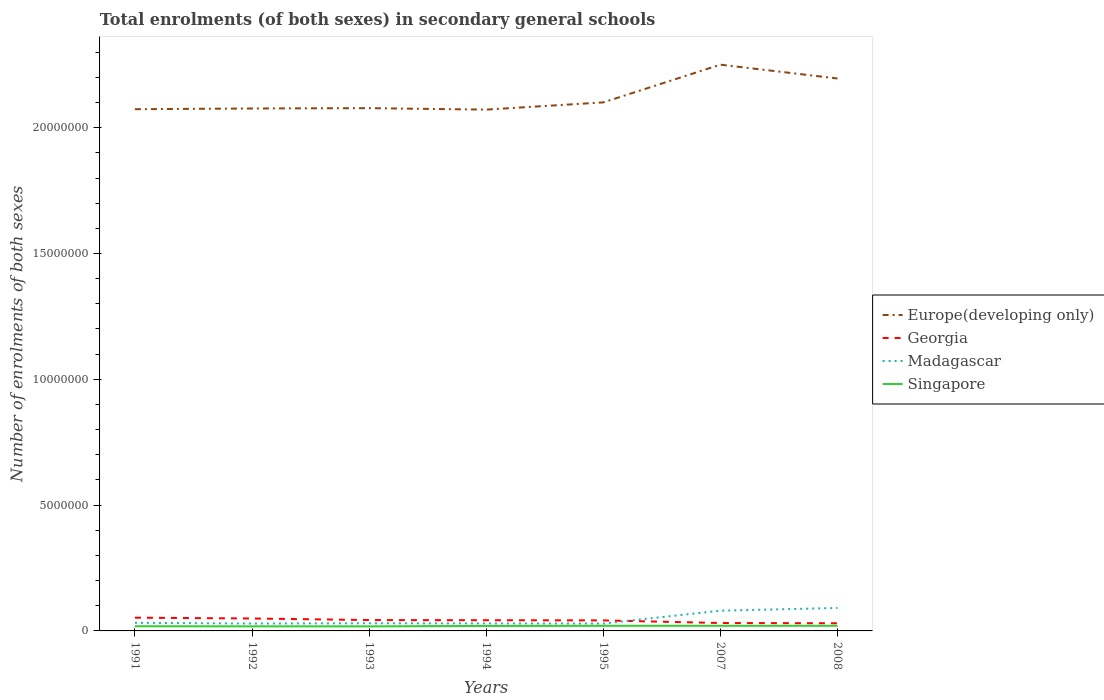Does the line corresponding to Madagascar intersect with the line corresponding to Europe(developing only)?
Provide a succinct answer. No. Across all years, what is the maximum number of enrolments in secondary schools in Europe(developing only)?
Ensure brevity in your answer.  2.07e+07. What is the total number of enrolments in secondary schools in Georgia in the graph?
Offer a very short reply. 1.91e+05. What is the difference between the highest and the second highest number of enrolments in secondary schools in Madagascar?
Offer a terse response. 6.19e+05. What is the difference between the highest and the lowest number of enrolments in secondary schools in Singapore?
Your answer should be very brief. 4. Are the values on the major ticks of Y-axis written in scientific E-notation?
Provide a succinct answer. No. Does the graph contain any zero values?
Offer a terse response. No. What is the title of the graph?
Your answer should be compact. Total enrolments (of both sexes) in secondary general schools. What is the label or title of the X-axis?
Ensure brevity in your answer.  Years. What is the label or title of the Y-axis?
Offer a very short reply. Number of enrolments of both sexes. What is the Number of enrolments of both sexes in Europe(developing only) in 1991?
Offer a terse response. 2.07e+07. What is the Number of enrolments of both sexes in Georgia in 1991?
Ensure brevity in your answer.  5.26e+05. What is the Number of enrolments of both sexes in Madagascar in 1991?
Give a very brief answer. 3.23e+05. What is the Number of enrolments of both sexes in Singapore in 1991?
Keep it short and to the point. 1.86e+05. What is the Number of enrolments of both sexes of Europe(developing only) in 1992?
Provide a succinct answer. 2.08e+07. What is the Number of enrolments of both sexes of Georgia in 1992?
Provide a short and direct response. 4.94e+05. What is the Number of enrolments of both sexes of Madagascar in 1992?
Your answer should be compact. 2.94e+05. What is the Number of enrolments of both sexes of Singapore in 1992?
Your answer should be very brief. 1.82e+05. What is the Number of enrolments of both sexes of Europe(developing only) in 1993?
Give a very brief answer. 2.08e+07. What is the Number of enrolments of both sexes in Georgia in 1993?
Give a very brief answer. 4.32e+05. What is the Number of enrolments of both sexes of Madagascar in 1993?
Keep it short and to the point. 3.05e+05. What is the Number of enrolments of both sexes in Singapore in 1993?
Offer a very short reply. 1.81e+05. What is the Number of enrolments of both sexes in Europe(developing only) in 1994?
Keep it short and to the point. 2.07e+07. What is the Number of enrolments of both sexes of Georgia in 1994?
Offer a terse response. 4.25e+05. What is the Number of enrolments of both sexes in Madagascar in 1994?
Your answer should be compact. 2.98e+05. What is the Number of enrolments of both sexes in Singapore in 1994?
Give a very brief answer. 1.98e+05. What is the Number of enrolments of both sexes of Europe(developing only) in 1995?
Give a very brief answer. 2.10e+07. What is the Number of enrolments of both sexes of Georgia in 1995?
Provide a short and direct response. 4.18e+05. What is the Number of enrolments of both sexes of Madagascar in 1995?
Provide a succinct answer. 2.94e+05. What is the Number of enrolments of both sexes in Singapore in 1995?
Your response must be concise. 2.04e+05. What is the Number of enrolments of both sexes of Europe(developing only) in 2007?
Keep it short and to the point. 2.25e+07. What is the Number of enrolments of both sexes in Georgia in 2007?
Your answer should be very brief. 3.14e+05. What is the Number of enrolments of both sexes in Madagascar in 2007?
Your response must be concise. 8.05e+05. What is the Number of enrolments of both sexes of Singapore in 2007?
Your answer should be very brief. 2.04e+05. What is the Number of enrolments of both sexes in Europe(developing only) in 2008?
Your response must be concise. 2.20e+07. What is the Number of enrolments of both sexes of Georgia in 2008?
Keep it short and to the point. 3.04e+05. What is the Number of enrolments of both sexes of Madagascar in 2008?
Your answer should be compact. 9.12e+05. What is the Number of enrolments of both sexes of Singapore in 2008?
Your answer should be compact. 2.04e+05. Across all years, what is the maximum Number of enrolments of both sexes of Europe(developing only)?
Your response must be concise. 2.25e+07. Across all years, what is the maximum Number of enrolments of both sexes of Georgia?
Give a very brief answer. 5.26e+05. Across all years, what is the maximum Number of enrolments of both sexes in Madagascar?
Keep it short and to the point. 9.12e+05. Across all years, what is the maximum Number of enrolments of both sexes in Singapore?
Keep it short and to the point. 2.04e+05. Across all years, what is the minimum Number of enrolments of both sexes of Europe(developing only)?
Keep it short and to the point. 2.07e+07. Across all years, what is the minimum Number of enrolments of both sexes in Georgia?
Provide a short and direct response. 3.04e+05. Across all years, what is the minimum Number of enrolments of both sexes of Madagascar?
Offer a terse response. 2.94e+05. Across all years, what is the minimum Number of enrolments of both sexes of Singapore?
Make the answer very short. 1.81e+05. What is the total Number of enrolments of both sexes of Europe(developing only) in the graph?
Make the answer very short. 1.48e+08. What is the total Number of enrolments of both sexes of Georgia in the graph?
Offer a terse response. 2.91e+06. What is the total Number of enrolments of both sexes of Madagascar in the graph?
Keep it short and to the point. 3.23e+06. What is the total Number of enrolments of both sexes in Singapore in the graph?
Give a very brief answer. 1.36e+06. What is the difference between the Number of enrolments of both sexes of Europe(developing only) in 1991 and that in 1992?
Your answer should be very brief. -2.84e+04. What is the difference between the Number of enrolments of both sexes in Georgia in 1991 and that in 1992?
Keep it short and to the point. 3.14e+04. What is the difference between the Number of enrolments of both sexes in Madagascar in 1991 and that in 1992?
Your response must be concise. 2.91e+04. What is the difference between the Number of enrolments of both sexes of Singapore in 1991 and that in 1992?
Provide a short and direct response. 3564. What is the difference between the Number of enrolments of both sexes of Europe(developing only) in 1991 and that in 1993?
Your answer should be very brief. -4.12e+04. What is the difference between the Number of enrolments of both sexes of Georgia in 1991 and that in 1993?
Give a very brief answer. 9.40e+04. What is the difference between the Number of enrolments of both sexes in Madagascar in 1991 and that in 1993?
Make the answer very short. 1.80e+04. What is the difference between the Number of enrolments of both sexes of Singapore in 1991 and that in 1993?
Your response must be concise. 4984. What is the difference between the Number of enrolments of both sexes of Europe(developing only) in 1991 and that in 1994?
Your answer should be very brief. 1.68e+04. What is the difference between the Number of enrolments of both sexes in Georgia in 1991 and that in 1994?
Your response must be concise. 1.00e+05. What is the difference between the Number of enrolments of both sexes of Madagascar in 1991 and that in 1994?
Make the answer very short. 2.45e+04. What is the difference between the Number of enrolments of both sexes of Singapore in 1991 and that in 1994?
Ensure brevity in your answer.  -1.23e+04. What is the difference between the Number of enrolments of both sexes of Europe(developing only) in 1991 and that in 1995?
Make the answer very short. -2.71e+05. What is the difference between the Number of enrolments of both sexes in Georgia in 1991 and that in 1995?
Offer a very short reply. 1.07e+05. What is the difference between the Number of enrolments of both sexes in Madagascar in 1991 and that in 1995?
Provide a succinct answer. 2.92e+04. What is the difference between the Number of enrolments of both sexes of Singapore in 1991 and that in 1995?
Ensure brevity in your answer.  -1.79e+04. What is the difference between the Number of enrolments of both sexes in Europe(developing only) in 1991 and that in 2007?
Provide a succinct answer. -1.77e+06. What is the difference between the Number of enrolments of both sexes of Georgia in 1991 and that in 2007?
Give a very brief answer. 2.12e+05. What is the difference between the Number of enrolments of both sexes of Madagascar in 1991 and that in 2007?
Make the answer very short. -4.83e+05. What is the difference between the Number of enrolments of both sexes in Singapore in 1991 and that in 2007?
Your answer should be compact. -1.86e+04. What is the difference between the Number of enrolments of both sexes of Europe(developing only) in 1991 and that in 2008?
Your answer should be very brief. -1.22e+06. What is the difference between the Number of enrolments of both sexes in Georgia in 1991 and that in 2008?
Give a very brief answer. 2.22e+05. What is the difference between the Number of enrolments of both sexes in Madagascar in 1991 and that in 2008?
Provide a short and direct response. -5.89e+05. What is the difference between the Number of enrolments of both sexes of Singapore in 1991 and that in 2008?
Offer a very short reply. -1.84e+04. What is the difference between the Number of enrolments of both sexes in Europe(developing only) in 1992 and that in 1993?
Make the answer very short. -1.28e+04. What is the difference between the Number of enrolments of both sexes in Georgia in 1992 and that in 1993?
Give a very brief answer. 6.26e+04. What is the difference between the Number of enrolments of both sexes in Madagascar in 1992 and that in 1993?
Provide a succinct answer. -1.11e+04. What is the difference between the Number of enrolments of both sexes in Singapore in 1992 and that in 1993?
Provide a short and direct response. 1420. What is the difference between the Number of enrolments of both sexes of Europe(developing only) in 1992 and that in 1994?
Ensure brevity in your answer.  4.53e+04. What is the difference between the Number of enrolments of both sexes in Georgia in 1992 and that in 1994?
Provide a short and direct response. 6.90e+04. What is the difference between the Number of enrolments of both sexes of Madagascar in 1992 and that in 1994?
Your answer should be very brief. -4520. What is the difference between the Number of enrolments of both sexes of Singapore in 1992 and that in 1994?
Provide a short and direct response. -1.58e+04. What is the difference between the Number of enrolments of both sexes of Europe(developing only) in 1992 and that in 1995?
Offer a terse response. -2.42e+05. What is the difference between the Number of enrolments of both sexes in Georgia in 1992 and that in 1995?
Keep it short and to the point. 7.60e+04. What is the difference between the Number of enrolments of both sexes of Madagascar in 1992 and that in 1995?
Your answer should be compact. 142. What is the difference between the Number of enrolments of both sexes of Singapore in 1992 and that in 1995?
Make the answer very short. -2.15e+04. What is the difference between the Number of enrolments of both sexes in Europe(developing only) in 1992 and that in 2007?
Your answer should be compact. -1.74e+06. What is the difference between the Number of enrolments of both sexes in Georgia in 1992 and that in 2007?
Provide a short and direct response. 1.81e+05. What is the difference between the Number of enrolments of both sexes of Madagascar in 1992 and that in 2007?
Your answer should be very brief. -5.12e+05. What is the difference between the Number of enrolments of both sexes in Singapore in 1992 and that in 2007?
Your response must be concise. -2.21e+04. What is the difference between the Number of enrolments of both sexes in Europe(developing only) in 1992 and that in 2008?
Offer a terse response. -1.19e+06. What is the difference between the Number of enrolments of both sexes of Georgia in 1992 and that in 2008?
Your answer should be compact. 1.91e+05. What is the difference between the Number of enrolments of both sexes of Madagascar in 1992 and that in 2008?
Make the answer very short. -6.18e+05. What is the difference between the Number of enrolments of both sexes of Singapore in 1992 and that in 2008?
Offer a very short reply. -2.20e+04. What is the difference between the Number of enrolments of both sexes of Europe(developing only) in 1993 and that in 1994?
Your response must be concise. 5.81e+04. What is the difference between the Number of enrolments of both sexes in Georgia in 1993 and that in 1994?
Provide a succinct answer. 6446. What is the difference between the Number of enrolments of both sexes of Madagascar in 1993 and that in 1994?
Ensure brevity in your answer.  6555. What is the difference between the Number of enrolments of both sexes in Singapore in 1993 and that in 1994?
Provide a short and direct response. -1.73e+04. What is the difference between the Number of enrolments of both sexes in Europe(developing only) in 1993 and that in 1995?
Keep it short and to the point. -2.30e+05. What is the difference between the Number of enrolments of both sexes of Georgia in 1993 and that in 1995?
Ensure brevity in your answer.  1.35e+04. What is the difference between the Number of enrolments of both sexes in Madagascar in 1993 and that in 1995?
Provide a succinct answer. 1.12e+04. What is the difference between the Number of enrolments of both sexes in Singapore in 1993 and that in 1995?
Your answer should be compact. -2.29e+04. What is the difference between the Number of enrolments of both sexes in Europe(developing only) in 1993 and that in 2007?
Ensure brevity in your answer.  -1.73e+06. What is the difference between the Number of enrolments of both sexes of Georgia in 1993 and that in 2007?
Your answer should be compact. 1.18e+05. What is the difference between the Number of enrolments of both sexes of Madagascar in 1993 and that in 2007?
Offer a terse response. -5.01e+05. What is the difference between the Number of enrolments of both sexes in Singapore in 1993 and that in 2007?
Give a very brief answer. -2.35e+04. What is the difference between the Number of enrolments of both sexes in Europe(developing only) in 1993 and that in 2008?
Keep it short and to the point. -1.18e+06. What is the difference between the Number of enrolments of both sexes of Georgia in 1993 and that in 2008?
Give a very brief answer. 1.28e+05. What is the difference between the Number of enrolments of both sexes of Madagascar in 1993 and that in 2008?
Your answer should be very brief. -6.07e+05. What is the difference between the Number of enrolments of both sexes of Singapore in 1993 and that in 2008?
Give a very brief answer. -2.34e+04. What is the difference between the Number of enrolments of both sexes in Europe(developing only) in 1994 and that in 1995?
Your response must be concise. -2.88e+05. What is the difference between the Number of enrolments of both sexes of Georgia in 1994 and that in 1995?
Your response must be concise. 7015. What is the difference between the Number of enrolments of both sexes in Madagascar in 1994 and that in 1995?
Your answer should be very brief. 4662. What is the difference between the Number of enrolments of both sexes in Singapore in 1994 and that in 1995?
Keep it short and to the point. -5681. What is the difference between the Number of enrolments of both sexes in Europe(developing only) in 1994 and that in 2007?
Make the answer very short. -1.79e+06. What is the difference between the Number of enrolments of both sexes in Georgia in 1994 and that in 2007?
Provide a succinct answer. 1.12e+05. What is the difference between the Number of enrolments of both sexes in Madagascar in 1994 and that in 2007?
Offer a very short reply. -5.07e+05. What is the difference between the Number of enrolments of both sexes of Singapore in 1994 and that in 2007?
Ensure brevity in your answer.  -6288. What is the difference between the Number of enrolments of both sexes of Europe(developing only) in 1994 and that in 2008?
Your answer should be very brief. -1.24e+06. What is the difference between the Number of enrolments of both sexes in Georgia in 1994 and that in 2008?
Offer a terse response. 1.22e+05. What is the difference between the Number of enrolments of both sexes of Madagascar in 1994 and that in 2008?
Your answer should be compact. -6.14e+05. What is the difference between the Number of enrolments of both sexes of Singapore in 1994 and that in 2008?
Offer a terse response. -6165. What is the difference between the Number of enrolments of both sexes of Europe(developing only) in 1995 and that in 2007?
Provide a short and direct response. -1.50e+06. What is the difference between the Number of enrolments of both sexes of Georgia in 1995 and that in 2007?
Keep it short and to the point. 1.05e+05. What is the difference between the Number of enrolments of both sexes of Madagascar in 1995 and that in 2007?
Your answer should be very brief. -5.12e+05. What is the difference between the Number of enrolments of both sexes of Singapore in 1995 and that in 2007?
Your answer should be very brief. -607. What is the difference between the Number of enrolments of both sexes in Europe(developing only) in 1995 and that in 2008?
Give a very brief answer. -9.49e+05. What is the difference between the Number of enrolments of both sexes of Georgia in 1995 and that in 2008?
Provide a succinct answer. 1.15e+05. What is the difference between the Number of enrolments of both sexes of Madagascar in 1995 and that in 2008?
Keep it short and to the point. -6.19e+05. What is the difference between the Number of enrolments of both sexes of Singapore in 1995 and that in 2008?
Your answer should be very brief. -484. What is the difference between the Number of enrolments of both sexes of Europe(developing only) in 2007 and that in 2008?
Make the answer very short. 5.50e+05. What is the difference between the Number of enrolments of both sexes in Georgia in 2007 and that in 2008?
Provide a succinct answer. 9931. What is the difference between the Number of enrolments of both sexes in Madagascar in 2007 and that in 2008?
Your answer should be compact. -1.07e+05. What is the difference between the Number of enrolments of both sexes in Singapore in 2007 and that in 2008?
Your answer should be very brief. 123. What is the difference between the Number of enrolments of both sexes in Europe(developing only) in 1991 and the Number of enrolments of both sexes in Georgia in 1992?
Provide a short and direct response. 2.02e+07. What is the difference between the Number of enrolments of both sexes of Europe(developing only) in 1991 and the Number of enrolments of both sexes of Madagascar in 1992?
Ensure brevity in your answer.  2.04e+07. What is the difference between the Number of enrolments of both sexes of Europe(developing only) in 1991 and the Number of enrolments of both sexes of Singapore in 1992?
Make the answer very short. 2.06e+07. What is the difference between the Number of enrolments of both sexes in Georgia in 1991 and the Number of enrolments of both sexes in Madagascar in 1992?
Give a very brief answer. 2.32e+05. What is the difference between the Number of enrolments of both sexes of Georgia in 1991 and the Number of enrolments of both sexes of Singapore in 1992?
Offer a terse response. 3.44e+05. What is the difference between the Number of enrolments of both sexes of Madagascar in 1991 and the Number of enrolments of both sexes of Singapore in 1992?
Ensure brevity in your answer.  1.41e+05. What is the difference between the Number of enrolments of both sexes in Europe(developing only) in 1991 and the Number of enrolments of both sexes in Georgia in 1993?
Offer a very short reply. 2.03e+07. What is the difference between the Number of enrolments of both sexes in Europe(developing only) in 1991 and the Number of enrolments of both sexes in Madagascar in 1993?
Give a very brief answer. 2.04e+07. What is the difference between the Number of enrolments of both sexes of Europe(developing only) in 1991 and the Number of enrolments of both sexes of Singapore in 1993?
Offer a terse response. 2.06e+07. What is the difference between the Number of enrolments of both sexes in Georgia in 1991 and the Number of enrolments of both sexes in Madagascar in 1993?
Offer a terse response. 2.21e+05. What is the difference between the Number of enrolments of both sexes of Georgia in 1991 and the Number of enrolments of both sexes of Singapore in 1993?
Make the answer very short. 3.45e+05. What is the difference between the Number of enrolments of both sexes in Madagascar in 1991 and the Number of enrolments of both sexes in Singapore in 1993?
Your answer should be very brief. 1.42e+05. What is the difference between the Number of enrolments of both sexes of Europe(developing only) in 1991 and the Number of enrolments of both sexes of Georgia in 1994?
Your answer should be very brief. 2.03e+07. What is the difference between the Number of enrolments of both sexes of Europe(developing only) in 1991 and the Number of enrolments of both sexes of Madagascar in 1994?
Provide a short and direct response. 2.04e+07. What is the difference between the Number of enrolments of both sexes of Europe(developing only) in 1991 and the Number of enrolments of both sexes of Singapore in 1994?
Provide a succinct answer. 2.05e+07. What is the difference between the Number of enrolments of both sexes in Georgia in 1991 and the Number of enrolments of both sexes in Madagascar in 1994?
Provide a short and direct response. 2.28e+05. What is the difference between the Number of enrolments of both sexes of Georgia in 1991 and the Number of enrolments of both sexes of Singapore in 1994?
Ensure brevity in your answer.  3.28e+05. What is the difference between the Number of enrolments of both sexes in Madagascar in 1991 and the Number of enrolments of both sexes in Singapore in 1994?
Give a very brief answer. 1.25e+05. What is the difference between the Number of enrolments of both sexes of Europe(developing only) in 1991 and the Number of enrolments of both sexes of Georgia in 1995?
Make the answer very short. 2.03e+07. What is the difference between the Number of enrolments of both sexes in Europe(developing only) in 1991 and the Number of enrolments of both sexes in Madagascar in 1995?
Ensure brevity in your answer.  2.04e+07. What is the difference between the Number of enrolments of both sexes in Europe(developing only) in 1991 and the Number of enrolments of both sexes in Singapore in 1995?
Provide a short and direct response. 2.05e+07. What is the difference between the Number of enrolments of both sexes of Georgia in 1991 and the Number of enrolments of both sexes of Madagascar in 1995?
Your answer should be very brief. 2.32e+05. What is the difference between the Number of enrolments of both sexes in Georgia in 1991 and the Number of enrolments of both sexes in Singapore in 1995?
Your answer should be compact. 3.22e+05. What is the difference between the Number of enrolments of both sexes in Madagascar in 1991 and the Number of enrolments of both sexes in Singapore in 1995?
Provide a succinct answer. 1.19e+05. What is the difference between the Number of enrolments of both sexes of Europe(developing only) in 1991 and the Number of enrolments of both sexes of Georgia in 2007?
Provide a succinct answer. 2.04e+07. What is the difference between the Number of enrolments of both sexes in Europe(developing only) in 1991 and the Number of enrolments of both sexes in Madagascar in 2007?
Provide a short and direct response. 1.99e+07. What is the difference between the Number of enrolments of both sexes in Europe(developing only) in 1991 and the Number of enrolments of both sexes in Singapore in 2007?
Your answer should be compact. 2.05e+07. What is the difference between the Number of enrolments of both sexes in Georgia in 1991 and the Number of enrolments of both sexes in Madagascar in 2007?
Provide a short and direct response. -2.80e+05. What is the difference between the Number of enrolments of both sexes in Georgia in 1991 and the Number of enrolments of both sexes in Singapore in 2007?
Provide a short and direct response. 3.22e+05. What is the difference between the Number of enrolments of both sexes in Madagascar in 1991 and the Number of enrolments of both sexes in Singapore in 2007?
Offer a terse response. 1.19e+05. What is the difference between the Number of enrolments of both sexes of Europe(developing only) in 1991 and the Number of enrolments of both sexes of Georgia in 2008?
Your response must be concise. 2.04e+07. What is the difference between the Number of enrolments of both sexes in Europe(developing only) in 1991 and the Number of enrolments of both sexes in Madagascar in 2008?
Make the answer very short. 1.98e+07. What is the difference between the Number of enrolments of both sexes in Europe(developing only) in 1991 and the Number of enrolments of both sexes in Singapore in 2008?
Provide a short and direct response. 2.05e+07. What is the difference between the Number of enrolments of both sexes of Georgia in 1991 and the Number of enrolments of both sexes of Madagascar in 2008?
Provide a short and direct response. -3.86e+05. What is the difference between the Number of enrolments of both sexes in Georgia in 1991 and the Number of enrolments of both sexes in Singapore in 2008?
Provide a succinct answer. 3.22e+05. What is the difference between the Number of enrolments of both sexes of Madagascar in 1991 and the Number of enrolments of both sexes of Singapore in 2008?
Provide a succinct answer. 1.19e+05. What is the difference between the Number of enrolments of both sexes in Europe(developing only) in 1992 and the Number of enrolments of both sexes in Georgia in 1993?
Make the answer very short. 2.03e+07. What is the difference between the Number of enrolments of both sexes in Europe(developing only) in 1992 and the Number of enrolments of both sexes in Madagascar in 1993?
Make the answer very short. 2.05e+07. What is the difference between the Number of enrolments of both sexes in Europe(developing only) in 1992 and the Number of enrolments of both sexes in Singapore in 1993?
Offer a very short reply. 2.06e+07. What is the difference between the Number of enrolments of both sexes of Georgia in 1992 and the Number of enrolments of both sexes of Madagascar in 1993?
Your answer should be very brief. 1.90e+05. What is the difference between the Number of enrolments of both sexes of Georgia in 1992 and the Number of enrolments of both sexes of Singapore in 1993?
Offer a very short reply. 3.14e+05. What is the difference between the Number of enrolments of both sexes of Madagascar in 1992 and the Number of enrolments of both sexes of Singapore in 1993?
Provide a short and direct response. 1.13e+05. What is the difference between the Number of enrolments of both sexes in Europe(developing only) in 1992 and the Number of enrolments of both sexes in Georgia in 1994?
Offer a terse response. 2.03e+07. What is the difference between the Number of enrolments of both sexes in Europe(developing only) in 1992 and the Number of enrolments of both sexes in Madagascar in 1994?
Offer a very short reply. 2.05e+07. What is the difference between the Number of enrolments of both sexes in Europe(developing only) in 1992 and the Number of enrolments of both sexes in Singapore in 1994?
Your answer should be very brief. 2.06e+07. What is the difference between the Number of enrolments of both sexes in Georgia in 1992 and the Number of enrolments of both sexes in Madagascar in 1994?
Your answer should be very brief. 1.96e+05. What is the difference between the Number of enrolments of both sexes in Georgia in 1992 and the Number of enrolments of both sexes in Singapore in 1994?
Offer a terse response. 2.96e+05. What is the difference between the Number of enrolments of both sexes of Madagascar in 1992 and the Number of enrolments of both sexes of Singapore in 1994?
Your answer should be compact. 9.57e+04. What is the difference between the Number of enrolments of both sexes in Europe(developing only) in 1992 and the Number of enrolments of both sexes in Georgia in 1995?
Ensure brevity in your answer.  2.03e+07. What is the difference between the Number of enrolments of both sexes of Europe(developing only) in 1992 and the Number of enrolments of both sexes of Madagascar in 1995?
Give a very brief answer. 2.05e+07. What is the difference between the Number of enrolments of both sexes in Europe(developing only) in 1992 and the Number of enrolments of both sexes in Singapore in 1995?
Give a very brief answer. 2.06e+07. What is the difference between the Number of enrolments of both sexes of Georgia in 1992 and the Number of enrolments of both sexes of Madagascar in 1995?
Give a very brief answer. 2.01e+05. What is the difference between the Number of enrolments of both sexes in Georgia in 1992 and the Number of enrolments of both sexes in Singapore in 1995?
Keep it short and to the point. 2.91e+05. What is the difference between the Number of enrolments of both sexes in Madagascar in 1992 and the Number of enrolments of both sexes in Singapore in 1995?
Offer a very short reply. 9.01e+04. What is the difference between the Number of enrolments of both sexes in Europe(developing only) in 1992 and the Number of enrolments of both sexes in Georgia in 2007?
Offer a very short reply. 2.04e+07. What is the difference between the Number of enrolments of both sexes in Europe(developing only) in 1992 and the Number of enrolments of both sexes in Madagascar in 2007?
Provide a succinct answer. 2.00e+07. What is the difference between the Number of enrolments of both sexes of Europe(developing only) in 1992 and the Number of enrolments of both sexes of Singapore in 2007?
Keep it short and to the point. 2.06e+07. What is the difference between the Number of enrolments of both sexes of Georgia in 1992 and the Number of enrolments of both sexes of Madagascar in 2007?
Give a very brief answer. -3.11e+05. What is the difference between the Number of enrolments of both sexes of Georgia in 1992 and the Number of enrolments of both sexes of Singapore in 2007?
Offer a very short reply. 2.90e+05. What is the difference between the Number of enrolments of both sexes of Madagascar in 1992 and the Number of enrolments of both sexes of Singapore in 2007?
Make the answer very short. 8.95e+04. What is the difference between the Number of enrolments of both sexes of Europe(developing only) in 1992 and the Number of enrolments of both sexes of Georgia in 2008?
Your answer should be very brief. 2.05e+07. What is the difference between the Number of enrolments of both sexes in Europe(developing only) in 1992 and the Number of enrolments of both sexes in Madagascar in 2008?
Your answer should be compact. 1.99e+07. What is the difference between the Number of enrolments of both sexes of Europe(developing only) in 1992 and the Number of enrolments of both sexes of Singapore in 2008?
Ensure brevity in your answer.  2.06e+07. What is the difference between the Number of enrolments of both sexes of Georgia in 1992 and the Number of enrolments of both sexes of Madagascar in 2008?
Your response must be concise. -4.18e+05. What is the difference between the Number of enrolments of both sexes of Georgia in 1992 and the Number of enrolments of both sexes of Singapore in 2008?
Keep it short and to the point. 2.90e+05. What is the difference between the Number of enrolments of both sexes of Madagascar in 1992 and the Number of enrolments of both sexes of Singapore in 2008?
Make the answer very short. 8.96e+04. What is the difference between the Number of enrolments of both sexes of Europe(developing only) in 1993 and the Number of enrolments of both sexes of Georgia in 1994?
Provide a succinct answer. 2.04e+07. What is the difference between the Number of enrolments of both sexes in Europe(developing only) in 1993 and the Number of enrolments of both sexes in Madagascar in 1994?
Keep it short and to the point. 2.05e+07. What is the difference between the Number of enrolments of both sexes in Europe(developing only) in 1993 and the Number of enrolments of both sexes in Singapore in 1994?
Offer a terse response. 2.06e+07. What is the difference between the Number of enrolments of both sexes in Georgia in 1993 and the Number of enrolments of both sexes in Madagascar in 1994?
Make the answer very short. 1.34e+05. What is the difference between the Number of enrolments of both sexes in Georgia in 1993 and the Number of enrolments of both sexes in Singapore in 1994?
Offer a terse response. 2.34e+05. What is the difference between the Number of enrolments of both sexes in Madagascar in 1993 and the Number of enrolments of both sexes in Singapore in 1994?
Your response must be concise. 1.07e+05. What is the difference between the Number of enrolments of both sexes in Europe(developing only) in 1993 and the Number of enrolments of both sexes in Georgia in 1995?
Provide a succinct answer. 2.04e+07. What is the difference between the Number of enrolments of both sexes of Europe(developing only) in 1993 and the Number of enrolments of both sexes of Madagascar in 1995?
Your response must be concise. 2.05e+07. What is the difference between the Number of enrolments of both sexes in Europe(developing only) in 1993 and the Number of enrolments of both sexes in Singapore in 1995?
Keep it short and to the point. 2.06e+07. What is the difference between the Number of enrolments of both sexes of Georgia in 1993 and the Number of enrolments of both sexes of Madagascar in 1995?
Your answer should be very brief. 1.38e+05. What is the difference between the Number of enrolments of both sexes in Georgia in 1993 and the Number of enrolments of both sexes in Singapore in 1995?
Ensure brevity in your answer.  2.28e+05. What is the difference between the Number of enrolments of both sexes in Madagascar in 1993 and the Number of enrolments of both sexes in Singapore in 1995?
Provide a short and direct response. 1.01e+05. What is the difference between the Number of enrolments of both sexes in Europe(developing only) in 1993 and the Number of enrolments of both sexes in Georgia in 2007?
Provide a succinct answer. 2.05e+07. What is the difference between the Number of enrolments of both sexes in Europe(developing only) in 1993 and the Number of enrolments of both sexes in Madagascar in 2007?
Provide a short and direct response. 2.00e+07. What is the difference between the Number of enrolments of both sexes of Europe(developing only) in 1993 and the Number of enrolments of both sexes of Singapore in 2007?
Your response must be concise. 2.06e+07. What is the difference between the Number of enrolments of both sexes in Georgia in 1993 and the Number of enrolments of both sexes in Madagascar in 2007?
Provide a short and direct response. -3.74e+05. What is the difference between the Number of enrolments of both sexes in Georgia in 1993 and the Number of enrolments of both sexes in Singapore in 2007?
Your answer should be compact. 2.28e+05. What is the difference between the Number of enrolments of both sexes in Madagascar in 1993 and the Number of enrolments of both sexes in Singapore in 2007?
Keep it short and to the point. 1.01e+05. What is the difference between the Number of enrolments of both sexes in Europe(developing only) in 1993 and the Number of enrolments of both sexes in Georgia in 2008?
Make the answer very short. 2.05e+07. What is the difference between the Number of enrolments of both sexes of Europe(developing only) in 1993 and the Number of enrolments of both sexes of Madagascar in 2008?
Provide a short and direct response. 1.99e+07. What is the difference between the Number of enrolments of both sexes of Europe(developing only) in 1993 and the Number of enrolments of both sexes of Singapore in 2008?
Keep it short and to the point. 2.06e+07. What is the difference between the Number of enrolments of both sexes in Georgia in 1993 and the Number of enrolments of both sexes in Madagascar in 2008?
Keep it short and to the point. -4.80e+05. What is the difference between the Number of enrolments of both sexes of Georgia in 1993 and the Number of enrolments of both sexes of Singapore in 2008?
Offer a terse response. 2.28e+05. What is the difference between the Number of enrolments of both sexes in Madagascar in 1993 and the Number of enrolments of both sexes in Singapore in 2008?
Offer a terse response. 1.01e+05. What is the difference between the Number of enrolments of both sexes in Europe(developing only) in 1994 and the Number of enrolments of both sexes in Georgia in 1995?
Make the answer very short. 2.03e+07. What is the difference between the Number of enrolments of both sexes in Europe(developing only) in 1994 and the Number of enrolments of both sexes in Madagascar in 1995?
Offer a very short reply. 2.04e+07. What is the difference between the Number of enrolments of both sexes of Europe(developing only) in 1994 and the Number of enrolments of both sexes of Singapore in 1995?
Your answer should be very brief. 2.05e+07. What is the difference between the Number of enrolments of both sexes of Georgia in 1994 and the Number of enrolments of both sexes of Madagascar in 1995?
Make the answer very short. 1.32e+05. What is the difference between the Number of enrolments of both sexes in Georgia in 1994 and the Number of enrolments of both sexes in Singapore in 1995?
Keep it short and to the point. 2.22e+05. What is the difference between the Number of enrolments of both sexes of Madagascar in 1994 and the Number of enrolments of both sexes of Singapore in 1995?
Provide a short and direct response. 9.46e+04. What is the difference between the Number of enrolments of both sexes in Europe(developing only) in 1994 and the Number of enrolments of both sexes in Georgia in 2007?
Offer a terse response. 2.04e+07. What is the difference between the Number of enrolments of both sexes in Europe(developing only) in 1994 and the Number of enrolments of both sexes in Madagascar in 2007?
Make the answer very short. 1.99e+07. What is the difference between the Number of enrolments of both sexes in Europe(developing only) in 1994 and the Number of enrolments of both sexes in Singapore in 2007?
Your response must be concise. 2.05e+07. What is the difference between the Number of enrolments of both sexes in Georgia in 1994 and the Number of enrolments of both sexes in Madagascar in 2007?
Give a very brief answer. -3.80e+05. What is the difference between the Number of enrolments of both sexes in Georgia in 1994 and the Number of enrolments of both sexes in Singapore in 2007?
Your answer should be compact. 2.21e+05. What is the difference between the Number of enrolments of both sexes in Madagascar in 1994 and the Number of enrolments of both sexes in Singapore in 2007?
Offer a terse response. 9.40e+04. What is the difference between the Number of enrolments of both sexes in Europe(developing only) in 1994 and the Number of enrolments of both sexes in Georgia in 2008?
Ensure brevity in your answer.  2.04e+07. What is the difference between the Number of enrolments of both sexes in Europe(developing only) in 1994 and the Number of enrolments of both sexes in Madagascar in 2008?
Make the answer very short. 1.98e+07. What is the difference between the Number of enrolments of both sexes of Europe(developing only) in 1994 and the Number of enrolments of both sexes of Singapore in 2008?
Make the answer very short. 2.05e+07. What is the difference between the Number of enrolments of both sexes of Georgia in 1994 and the Number of enrolments of both sexes of Madagascar in 2008?
Offer a very short reply. -4.87e+05. What is the difference between the Number of enrolments of both sexes in Georgia in 1994 and the Number of enrolments of both sexes in Singapore in 2008?
Give a very brief answer. 2.21e+05. What is the difference between the Number of enrolments of both sexes of Madagascar in 1994 and the Number of enrolments of both sexes of Singapore in 2008?
Make the answer very short. 9.41e+04. What is the difference between the Number of enrolments of both sexes of Europe(developing only) in 1995 and the Number of enrolments of both sexes of Georgia in 2007?
Your answer should be very brief. 2.07e+07. What is the difference between the Number of enrolments of both sexes of Europe(developing only) in 1995 and the Number of enrolments of both sexes of Madagascar in 2007?
Provide a short and direct response. 2.02e+07. What is the difference between the Number of enrolments of both sexes of Europe(developing only) in 1995 and the Number of enrolments of both sexes of Singapore in 2007?
Offer a terse response. 2.08e+07. What is the difference between the Number of enrolments of both sexes in Georgia in 1995 and the Number of enrolments of both sexes in Madagascar in 2007?
Offer a very short reply. -3.87e+05. What is the difference between the Number of enrolments of both sexes of Georgia in 1995 and the Number of enrolments of both sexes of Singapore in 2007?
Offer a terse response. 2.14e+05. What is the difference between the Number of enrolments of both sexes of Madagascar in 1995 and the Number of enrolments of both sexes of Singapore in 2007?
Your answer should be very brief. 8.93e+04. What is the difference between the Number of enrolments of both sexes in Europe(developing only) in 1995 and the Number of enrolments of both sexes in Georgia in 2008?
Give a very brief answer. 2.07e+07. What is the difference between the Number of enrolments of both sexes of Europe(developing only) in 1995 and the Number of enrolments of both sexes of Madagascar in 2008?
Your answer should be very brief. 2.01e+07. What is the difference between the Number of enrolments of both sexes in Europe(developing only) in 1995 and the Number of enrolments of both sexes in Singapore in 2008?
Give a very brief answer. 2.08e+07. What is the difference between the Number of enrolments of both sexes of Georgia in 1995 and the Number of enrolments of both sexes of Madagascar in 2008?
Ensure brevity in your answer.  -4.94e+05. What is the difference between the Number of enrolments of both sexes of Georgia in 1995 and the Number of enrolments of both sexes of Singapore in 2008?
Keep it short and to the point. 2.14e+05. What is the difference between the Number of enrolments of both sexes of Madagascar in 1995 and the Number of enrolments of both sexes of Singapore in 2008?
Make the answer very short. 8.94e+04. What is the difference between the Number of enrolments of both sexes of Europe(developing only) in 2007 and the Number of enrolments of both sexes of Georgia in 2008?
Provide a succinct answer. 2.22e+07. What is the difference between the Number of enrolments of both sexes in Europe(developing only) in 2007 and the Number of enrolments of both sexes in Madagascar in 2008?
Offer a terse response. 2.16e+07. What is the difference between the Number of enrolments of both sexes in Europe(developing only) in 2007 and the Number of enrolments of both sexes in Singapore in 2008?
Offer a very short reply. 2.23e+07. What is the difference between the Number of enrolments of both sexes in Georgia in 2007 and the Number of enrolments of both sexes in Madagascar in 2008?
Offer a very short reply. -5.98e+05. What is the difference between the Number of enrolments of both sexes of Georgia in 2007 and the Number of enrolments of both sexes of Singapore in 2008?
Provide a short and direct response. 1.10e+05. What is the difference between the Number of enrolments of both sexes in Madagascar in 2007 and the Number of enrolments of both sexes in Singapore in 2008?
Make the answer very short. 6.01e+05. What is the average Number of enrolments of both sexes of Europe(developing only) per year?
Provide a succinct answer. 2.12e+07. What is the average Number of enrolments of both sexes in Georgia per year?
Offer a very short reply. 4.16e+05. What is the average Number of enrolments of both sexes in Madagascar per year?
Ensure brevity in your answer.  4.62e+05. What is the average Number of enrolments of both sexes in Singapore per year?
Provide a succinct answer. 1.94e+05. In the year 1991, what is the difference between the Number of enrolments of both sexes of Europe(developing only) and Number of enrolments of both sexes of Georgia?
Your answer should be compact. 2.02e+07. In the year 1991, what is the difference between the Number of enrolments of both sexes in Europe(developing only) and Number of enrolments of both sexes in Madagascar?
Give a very brief answer. 2.04e+07. In the year 1991, what is the difference between the Number of enrolments of both sexes in Europe(developing only) and Number of enrolments of both sexes in Singapore?
Your response must be concise. 2.05e+07. In the year 1991, what is the difference between the Number of enrolments of both sexes in Georgia and Number of enrolments of both sexes in Madagascar?
Make the answer very short. 2.03e+05. In the year 1991, what is the difference between the Number of enrolments of both sexes of Georgia and Number of enrolments of both sexes of Singapore?
Keep it short and to the point. 3.40e+05. In the year 1991, what is the difference between the Number of enrolments of both sexes of Madagascar and Number of enrolments of both sexes of Singapore?
Your answer should be very brief. 1.37e+05. In the year 1992, what is the difference between the Number of enrolments of both sexes of Europe(developing only) and Number of enrolments of both sexes of Georgia?
Offer a very short reply. 2.03e+07. In the year 1992, what is the difference between the Number of enrolments of both sexes in Europe(developing only) and Number of enrolments of both sexes in Madagascar?
Offer a very short reply. 2.05e+07. In the year 1992, what is the difference between the Number of enrolments of both sexes of Europe(developing only) and Number of enrolments of both sexes of Singapore?
Your response must be concise. 2.06e+07. In the year 1992, what is the difference between the Number of enrolments of both sexes in Georgia and Number of enrolments of both sexes in Madagascar?
Provide a short and direct response. 2.01e+05. In the year 1992, what is the difference between the Number of enrolments of both sexes of Georgia and Number of enrolments of both sexes of Singapore?
Your answer should be very brief. 3.12e+05. In the year 1992, what is the difference between the Number of enrolments of both sexes in Madagascar and Number of enrolments of both sexes in Singapore?
Make the answer very short. 1.12e+05. In the year 1993, what is the difference between the Number of enrolments of both sexes in Europe(developing only) and Number of enrolments of both sexes in Georgia?
Give a very brief answer. 2.03e+07. In the year 1993, what is the difference between the Number of enrolments of both sexes of Europe(developing only) and Number of enrolments of both sexes of Madagascar?
Keep it short and to the point. 2.05e+07. In the year 1993, what is the difference between the Number of enrolments of both sexes of Europe(developing only) and Number of enrolments of both sexes of Singapore?
Ensure brevity in your answer.  2.06e+07. In the year 1993, what is the difference between the Number of enrolments of both sexes of Georgia and Number of enrolments of both sexes of Madagascar?
Your answer should be very brief. 1.27e+05. In the year 1993, what is the difference between the Number of enrolments of both sexes in Georgia and Number of enrolments of both sexes in Singapore?
Ensure brevity in your answer.  2.51e+05. In the year 1993, what is the difference between the Number of enrolments of both sexes in Madagascar and Number of enrolments of both sexes in Singapore?
Offer a very short reply. 1.24e+05. In the year 1994, what is the difference between the Number of enrolments of both sexes in Europe(developing only) and Number of enrolments of both sexes in Georgia?
Keep it short and to the point. 2.03e+07. In the year 1994, what is the difference between the Number of enrolments of both sexes in Europe(developing only) and Number of enrolments of both sexes in Madagascar?
Make the answer very short. 2.04e+07. In the year 1994, what is the difference between the Number of enrolments of both sexes in Europe(developing only) and Number of enrolments of both sexes in Singapore?
Offer a very short reply. 2.05e+07. In the year 1994, what is the difference between the Number of enrolments of both sexes of Georgia and Number of enrolments of both sexes of Madagascar?
Your answer should be very brief. 1.27e+05. In the year 1994, what is the difference between the Number of enrolments of both sexes in Georgia and Number of enrolments of both sexes in Singapore?
Provide a short and direct response. 2.27e+05. In the year 1994, what is the difference between the Number of enrolments of both sexes in Madagascar and Number of enrolments of both sexes in Singapore?
Make the answer very short. 1.00e+05. In the year 1995, what is the difference between the Number of enrolments of both sexes of Europe(developing only) and Number of enrolments of both sexes of Georgia?
Ensure brevity in your answer.  2.06e+07. In the year 1995, what is the difference between the Number of enrolments of both sexes in Europe(developing only) and Number of enrolments of both sexes in Madagascar?
Give a very brief answer. 2.07e+07. In the year 1995, what is the difference between the Number of enrolments of both sexes of Europe(developing only) and Number of enrolments of both sexes of Singapore?
Ensure brevity in your answer.  2.08e+07. In the year 1995, what is the difference between the Number of enrolments of both sexes of Georgia and Number of enrolments of both sexes of Madagascar?
Offer a very short reply. 1.25e+05. In the year 1995, what is the difference between the Number of enrolments of both sexes in Georgia and Number of enrolments of both sexes in Singapore?
Your answer should be very brief. 2.15e+05. In the year 1995, what is the difference between the Number of enrolments of both sexes in Madagascar and Number of enrolments of both sexes in Singapore?
Your answer should be very brief. 8.99e+04. In the year 2007, what is the difference between the Number of enrolments of both sexes in Europe(developing only) and Number of enrolments of both sexes in Georgia?
Ensure brevity in your answer.  2.22e+07. In the year 2007, what is the difference between the Number of enrolments of both sexes of Europe(developing only) and Number of enrolments of both sexes of Madagascar?
Keep it short and to the point. 2.17e+07. In the year 2007, what is the difference between the Number of enrolments of both sexes of Europe(developing only) and Number of enrolments of both sexes of Singapore?
Your answer should be compact. 2.23e+07. In the year 2007, what is the difference between the Number of enrolments of both sexes in Georgia and Number of enrolments of both sexes in Madagascar?
Offer a terse response. -4.92e+05. In the year 2007, what is the difference between the Number of enrolments of both sexes of Georgia and Number of enrolments of both sexes of Singapore?
Provide a short and direct response. 1.09e+05. In the year 2007, what is the difference between the Number of enrolments of both sexes in Madagascar and Number of enrolments of both sexes in Singapore?
Provide a short and direct response. 6.01e+05. In the year 2008, what is the difference between the Number of enrolments of both sexes in Europe(developing only) and Number of enrolments of both sexes in Georgia?
Provide a succinct answer. 2.17e+07. In the year 2008, what is the difference between the Number of enrolments of both sexes in Europe(developing only) and Number of enrolments of both sexes in Madagascar?
Offer a terse response. 2.10e+07. In the year 2008, what is the difference between the Number of enrolments of both sexes of Europe(developing only) and Number of enrolments of both sexes of Singapore?
Make the answer very short. 2.18e+07. In the year 2008, what is the difference between the Number of enrolments of both sexes in Georgia and Number of enrolments of both sexes in Madagascar?
Your answer should be compact. -6.08e+05. In the year 2008, what is the difference between the Number of enrolments of both sexes in Georgia and Number of enrolments of both sexes in Singapore?
Ensure brevity in your answer.  9.97e+04. In the year 2008, what is the difference between the Number of enrolments of both sexes of Madagascar and Number of enrolments of both sexes of Singapore?
Your answer should be very brief. 7.08e+05. What is the ratio of the Number of enrolments of both sexes in Europe(developing only) in 1991 to that in 1992?
Offer a very short reply. 1. What is the ratio of the Number of enrolments of both sexes of Georgia in 1991 to that in 1992?
Make the answer very short. 1.06. What is the ratio of the Number of enrolments of both sexes in Madagascar in 1991 to that in 1992?
Your response must be concise. 1.1. What is the ratio of the Number of enrolments of both sexes in Singapore in 1991 to that in 1992?
Your response must be concise. 1.02. What is the ratio of the Number of enrolments of both sexes of Europe(developing only) in 1991 to that in 1993?
Make the answer very short. 1. What is the ratio of the Number of enrolments of both sexes in Georgia in 1991 to that in 1993?
Provide a succinct answer. 1.22. What is the ratio of the Number of enrolments of both sexes in Madagascar in 1991 to that in 1993?
Give a very brief answer. 1.06. What is the ratio of the Number of enrolments of both sexes of Singapore in 1991 to that in 1993?
Your answer should be compact. 1.03. What is the ratio of the Number of enrolments of both sexes of Georgia in 1991 to that in 1994?
Your answer should be very brief. 1.24. What is the ratio of the Number of enrolments of both sexes in Madagascar in 1991 to that in 1994?
Your response must be concise. 1.08. What is the ratio of the Number of enrolments of both sexes of Singapore in 1991 to that in 1994?
Your response must be concise. 0.94. What is the ratio of the Number of enrolments of both sexes in Europe(developing only) in 1991 to that in 1995?
Ensure brevity in your answer.  0.99. What is the ratio of the Number of enrolments of both sexes of Georgia in 1991 to that in 1995?
Offer a very short reply. 1.26. What is the ratio of the Number of enrolments of both sexes in Madagascar in 1991 to that in 1995?
Offer a terse response. 1.1. What is the ratio of the Number of enrolments of both sexes in Singapore in 1991 to that in 1995?
Your answer should be very brief. 0.91. What is the ratio of the Number of enrolments of both sexes of Europe(developing only) in 1991 to that in 2007?
Offer a terse response. 0.92. What is the ratio of the Number of enrolments of both sexes in Georgia in 1991 to that in 2007?
Ensure brevity in your answer.  1.68. What is the ratio of the Number of enrolments of both sexes of Madagascar in 1991 to that in 2007?
Your response must be concise. 0.4. What is the ratio of the Number of enrolments of both sexes of Singapore in 1991 to that in 2007?
Make the answer very short. 0.91. What is the ratio of the Number of enrolments of both sexes in Georgia in 1991 to that in 2008?
Give a very brief answer. 1.73. What is the ratio of the Number of enrolments of both sexes in Madagascar in 1991 to that in 2008?
Keep it short and to the point. 0.35. What is the ratio of the Number of enrolments of both sexes of Singapore in 1991 to that in 2008?
Your answer should be compact. 0.91. What is the ratio of the Number of enrolments of both sexes in Europe(developing only) in 1992 to that in 1993?
Ensure brevity in your answer.  1. What is the ratio of the Number of enrolments of both sexes of Georgia in 1992 to that in 1993?
Provide a short and direct response. 1.14. What is the ratio of the Number of enrolments of both sexes in Madagascar in 1992 to that in 1993?
Keep it short and to the point. 0.96. What is the ratio of the Number of enrolments of both sexes of Singapore in 1992 to that in 1993?
Ensure brevity in your answer.  1.01. What is the ratio of the Number of enrolments of both sexes in Europe(developing only) in 1992 to that in 1994?
Give a very brief answer. 1. What is the ratio of the Number of enrolments of both sexes of Georgia in 1992 to that in 1994?
Give a very brief answer. 1.16. What is the ratio of the Number of enrolments of both sexes in Madagascar in 1992 to that in 1994?
Ensure brevity in your answer.  0.98. What is the ratio of the Number of enrolments of both sexes in Europe(developing only) in 1992 to that in 1995?
Your response must be concise. 0.99. What is the ratio of the Number of enrolments of both sexes in Georgia in 1992 to that in 1995?
Offer a very short reply. 1.18. What is the ratio of the Number of enrolments of both sexes in Singapore in 1992 to that in 1995?
Offer a very short reply. 0.89. What is the ratio of the Number of enrolments of both sexes of Europe(developing only) in 1992 to that in 2007?
Ensure brevity in your answer.  0.92. What is the ratio of the Number of enrolments of both sexes of Georgia in 1992 to that in 2007?
Offer a very short reply. 1.58. What is the ratio of the Number of enrolments of both sexes in Madagascar in 1992 to that in 2007?
Your response must be concise. 0.36. What is the ratio of the Number of enrolments of both sexes in Singapore in 1992 to that in 2007?
Your answer should be very brief. 0.89. What is the ratio of the Number of enrolments of both sexes in Europe(developing only) in 1992 to that in 2008?
Provide a succinct answer. 0.95. What is the ratio of the Number of enrolments of both sexes of Georgia in 1992 to that in 2008?
Provide a short and direct response. 1.63. What is the ratio of the Number of enrolments of both sexes in Madagascar in 1992 to that in 2008?
Provide a succinct answer. 0.32. What is the ratio of the Number of enrolments of both sexes in Singapore in 1992 to that in 2008?
Your response must be concise. 0.89. What is the ratio of the Number of enrolments of both sexes in Europe(developing only) in 1993 to that in 1994?
Ensure brevity in your answer.  1. What is the ratio of the Number of enrolments of both sexes in Georgia in 1993 to that in 1994?
Your answer should be compact. 1.02. What is the ratio of the Number of enrolments of both sexes of Madagascar in 1993 to that in 1994?
Provide a succinct answer. 1.02. What is the ratio of the Number of enrolments of both sexes of Singapore in 1993 to that in 1994?
Keep it short and to the point. 0.91. What is the ratio of the Number of enrolments of both sexes of Europe(developing only) in 1993 to that in 1995?
Your answer should be very brief. 0.99. What is the ratio of the Number of enrolments of both sexes of Georgia in 1993 to that in 1995?
Your answer should be compact. 1.03. What is the ratio of the Number of enrolments of both sexes in Madagascar in 1993 to that in 1995?
Provide a short and direct response. 1.04. What is the ratio of the Number of enrolments of both sexes in Singapore in 1993 to that in 1995?
Keep it short and to the point. 0.89. What is the ratio of the Number of enrolments of both sexes in Europe(developing only) in 1993 to that in 2007?
Offer a terse response. 0.92. What is the ratio of the Number of enrolments of both sexes of Georgia in 1993 to that in 2007?
Your answer should be compact. 1.38. What is the ratio of the Number of enrolments of both sexes in Madagascar in 1993 to that in 2007?
Your response must be concise. 0.38. What is the ratio of the Number of enrolments of both sexes of Singapore in 1993 to that in 2007?
Your response must be concise. 0.88. What is the ratio of the Number of enrolments of both sexes of Europe(developing only) in 1993 to that in 2008?
Make the answer very short. 0.95. What is the ratio of the Number of enrolments of both sexes of Georgia in 1993 to that in 2008?
Make the answer very short. 1.42. What is the ratio of the Number of enrolments of both sexes of Madagascar in 1993 to that in 2008?
Your answer should be compact. 0.33. What is the ratio of the Number of enrolments of both sexes of Singapore in 1993 to that in 2008?
Offer a very short reply. 0.89. What is the ratio of the Number of enrolments of both sexes in Europe(developing only) in 1994 to that in 1995?
Ensure brevity in your answer.  0.99. What is the ratio of the Number of enrolments of both sexes in Georgia in 1994 to that in 1995?
Your answer should be very brief. 1.02. What is the ratio of the Number of enrolments of both sexes in Madagascar in 1994 to that in 1995?
Keep it short and to the point. 1.02. What is the ratio of the Number of enrolments of both sexes in Singapore in 1994 to that in 1995?
Keep it short and to the point. 0.97. What is the ratio of the Number of enrolments of both sexes of Europe(developing only) in 1994 to that in 2007?
Offer a terse response. 0.92. What is the ratio of the Number of enrolments of both sexes in Georgia in 1994 to that in 2007?
Provide a succinct answer. 1.36. What is the ratio of the Number of enrolments of both sexes in Madagascar in 1994 to that in 2007?
Your response must be concise. 0.37. What is the ratio of the Number of enrolments of both sexes of Singapore in 1994 to that in 2007?
Provide a short and direct response. 0.97. What is the ratio of the Number of enrolments of both sexes of Europe(developing only) in 1994 to that in 2008?
Your response must be concise. 0.94. What is the ratio of the Number of enrolments of both sexes in Georgia in 1994 to that in 2008?
Provide a succinct answer. 1.4. What is the ratio of the Number of enrolments of both sexes of Madagascar in 1994 to that in 2008?
Provide a succinct answer. 0.33. What is the ratio of the Number of enrolments of both sexes in Singapore in 1994 to that in 2008?
Give a very brief answer. 0.97. What is the ratio of the Number of enrolments of both sexes in Europe(developing only) in 1995 to that in 2007?
Keep it short and to the point. 0.93. What is the ratio of the Number of enrolments of both sexes of Georgia in 1995 to that in 2007?
Make the answer very short. 1.33. What is the ratio of the Number of enrolments of both sexes of Madagascar in 1995 to that in 2007?
Keep it short and to the point. 0.36. What is the ratio of the Number of enrolments of both sexes in Singapore in 1995 to that in 2007?
Give a very brief answer. 1. What is the ratio of the Number of enrolments of both sexes of Europe(developing only) in 1995 to that in 2008?
Provide a short and direct response. 0.96. What is the ratio of the Number of enrolments of both sexes of Georgia in 1995 to that in 2008?
Your response must be concise. 1.38. What is the ratio of the Number of enrolments of both sexes of Madagascar in 1995 to that in 2008?
Provide a short and direct response. 0.32. What is the ratio of the Number of enrolments of both sexes in Europe(developing only) in 2007 to that in 2008?
Ensure brevity in your answer.  1.03. What is the ratio of the Number of enrolments of both sexes of Georgia in 2007 to that in 2008?
Give a very brief answer. 1.03. What is the ratio of the Number of enrolments of both sexes of Madagascar in 2007 to that in 2008?
Offer a terse response. 0.88. What is the difference between the highest and the second highest Number of enrolments of both sexes of Europe(developing only)?
Provide a succinct answer. 5.50e+05. What is the difference between the highest and the second highest Number of enrolments of both sexes in Georgia?
Offer a very short reply. 3.14e+04. What is the difference between the highest and the second highest Number of enrolments of both sexes of Madagascar?
Your answer should be compact. 1.07e+05. What is the difference between the highest and the second highest Number of enrolments of both sexes of Singapore?
Your response must be concise. 123. What is the difference between the highest and the lowest Number of enrolments of both sexes in Europe(developing only)?
Ensure brevity in your answer.  1.79e+06. What is the difference between the highest and the lowest Number of enrolments of both sexes of Georgia?
Provide a short and direct response. 2.22e+05. What is the difference between the highest and the lowest Number of enrolments of both sexes in Madagascar?
Offer a very short reply. 6.19e+05. What is the difference between the highest and the lowest Number of enrolments of both sexes of Singapore?
Ensure brevity in your answer.  2.35e+04. 